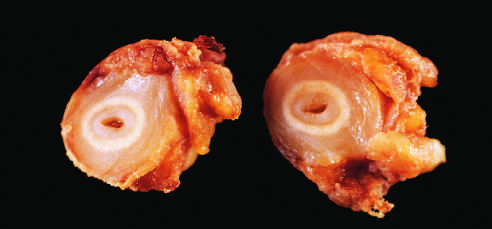what is the inner core of tan tissue?
Answer the question using a single word or phrase. The area of intimal hyperplasia 